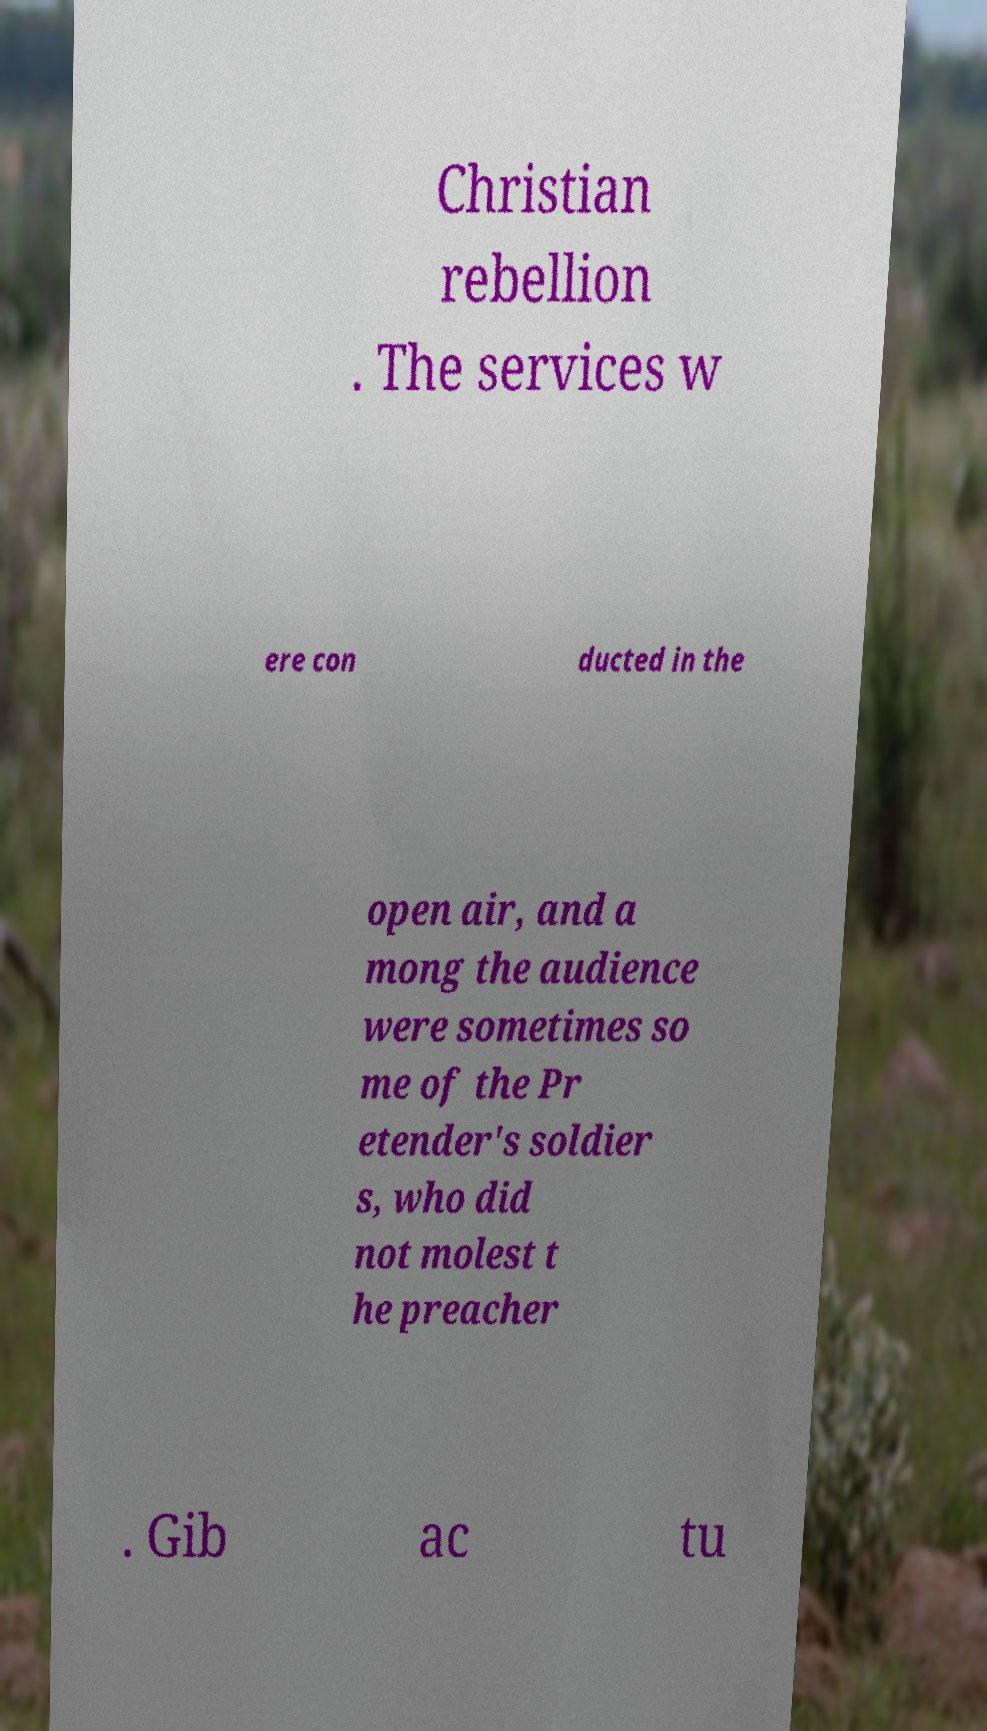There's text embedded in this image that I need extracted. Can you transcribe it verbatim? Christian rebellion . The services w ere con ducted in the open air, and a mong the audience were sometimes so me of the Pr etender's soldier s, who did not molest t he preacher . Gib ac tu 